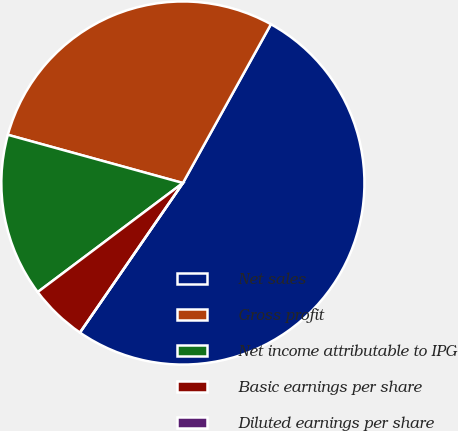<chart> <loc_0><loc_0><loc_500><loc_500><pie_chart><fcel>Net sales<fcel>Gross profit<fcel>Net income attributable to IPG<fcel>Basic earnings per share<fcel>Diluted earnings per share<nl><fcel>51.54%<fcel>28.78%<fcel>14.53%<fcel>5.15%<fcel>0.0%<nl></chart> 